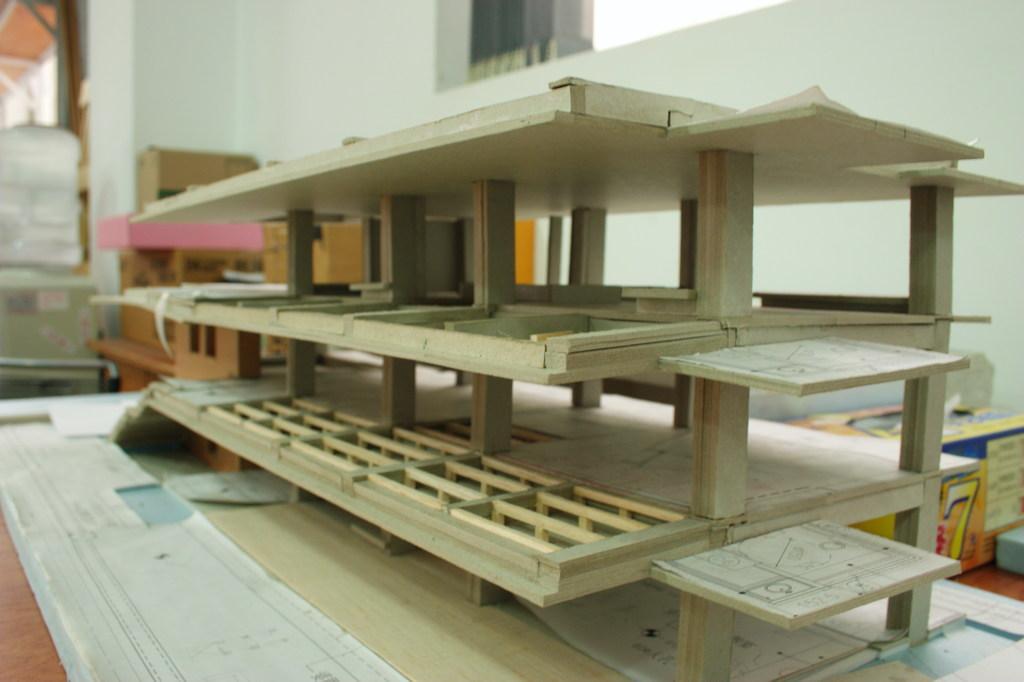In one or two sentences, can you explain what this image depicts? In this image I can see a scale model and there are cartons at the back. There is a wall at the back. 